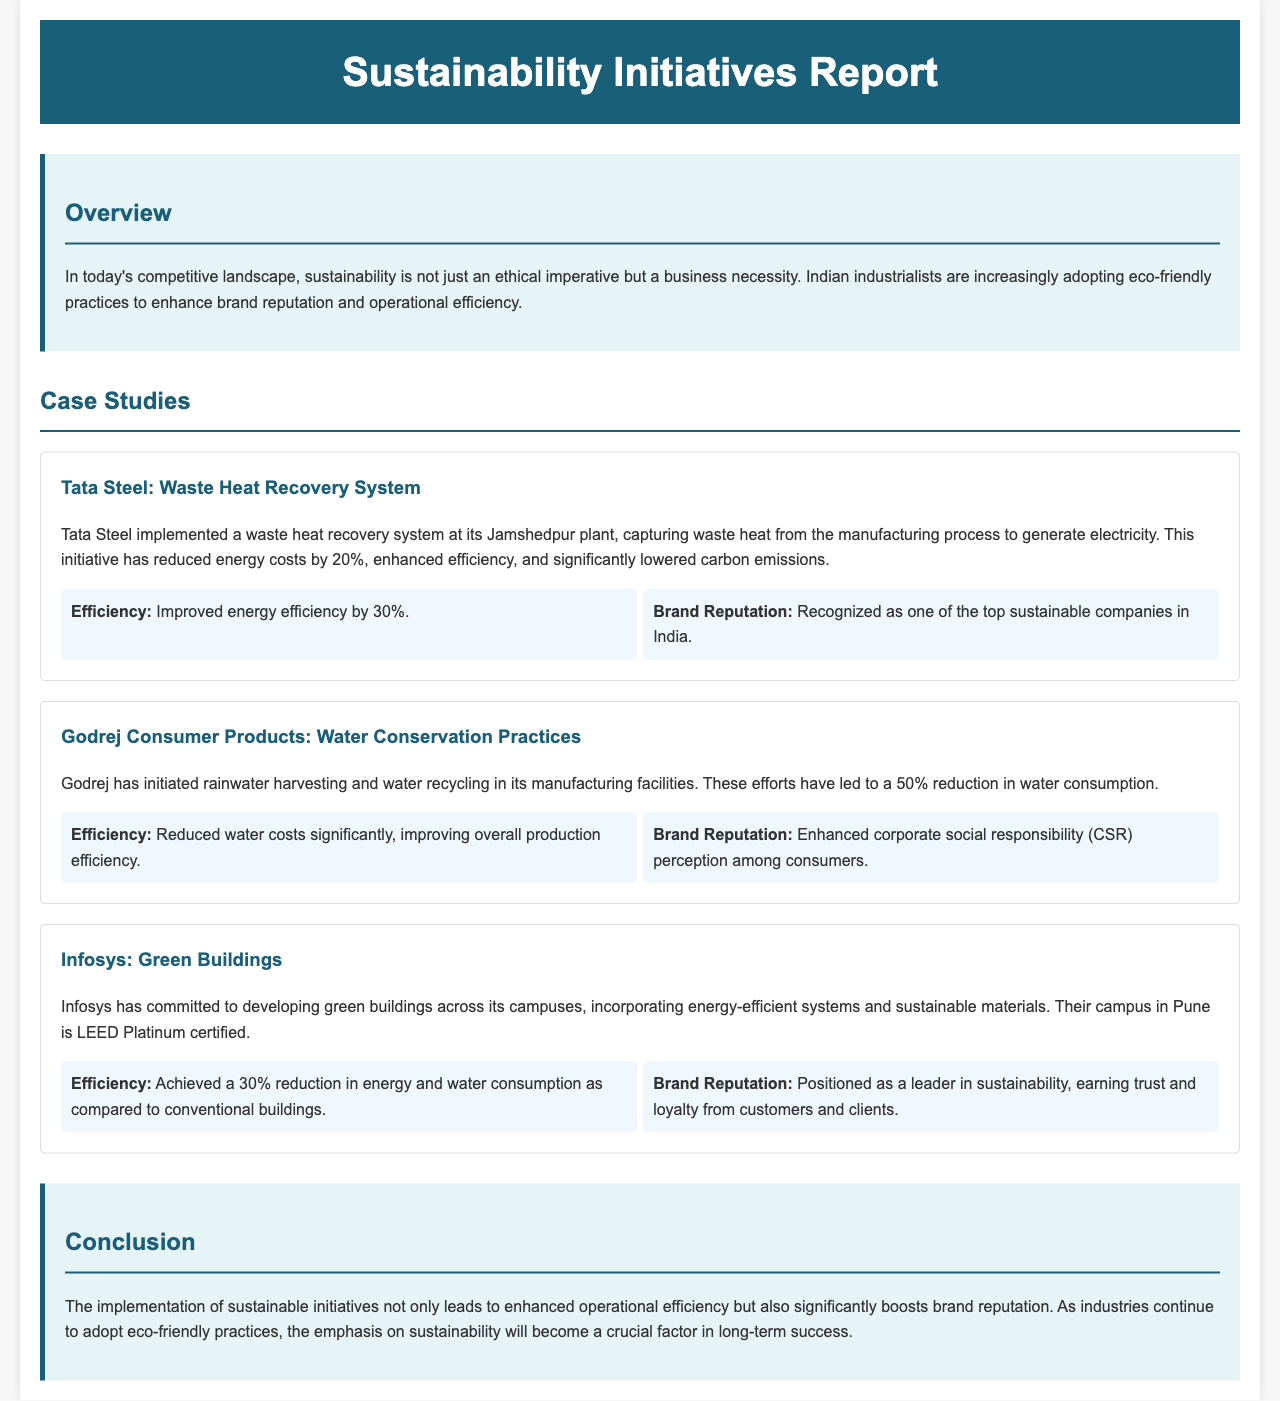What is the main focus of the report? The report emphasizes the importance of sustainability as a business necessity and its impact on efficiency and brand reputation.
Answer: Sustainability How much did Tata Steel reduce its energy costs? Tata Steel's initiative led to a reduction in energy costs by a specified amount.
Answer: 20% What eco-friendly practice did Godrej implement? The report mentions specific practices adopted by Godrej to conserve water.
Answer: Rainwater harvesting What was achieved at Infosys' Pune campus? The report states a certification level attained by Infosys for its campus in Pune.
Answer: LEED Platinum certified What percentage did Tata Steel improve energy efficiency by? The report details the percentage improvement in energy efficiency due to Tata Steel's initiatives.
Answer: 30% Which company is recognized as a leader in sustainability? The document highlights a company's reputation in sustainability, indicating its position in the market.
Answer: Infosys What impact did Godrej's practices have on water consumption? The report describes the effect of Godrej's initiatives on water use in production.
Answer: 50% reduction What is the conclusion about the implementation of sustainable initiatives? The document summarizes the overall impact of sustainability initiatives on operations and reputation.
Answer: Enhanced operational efficiency What is highlighted as critical for long-term success in the conclusion? The report concludes with a statement regarding the importance of sustainability for future business success.
Answer: Sustainability 